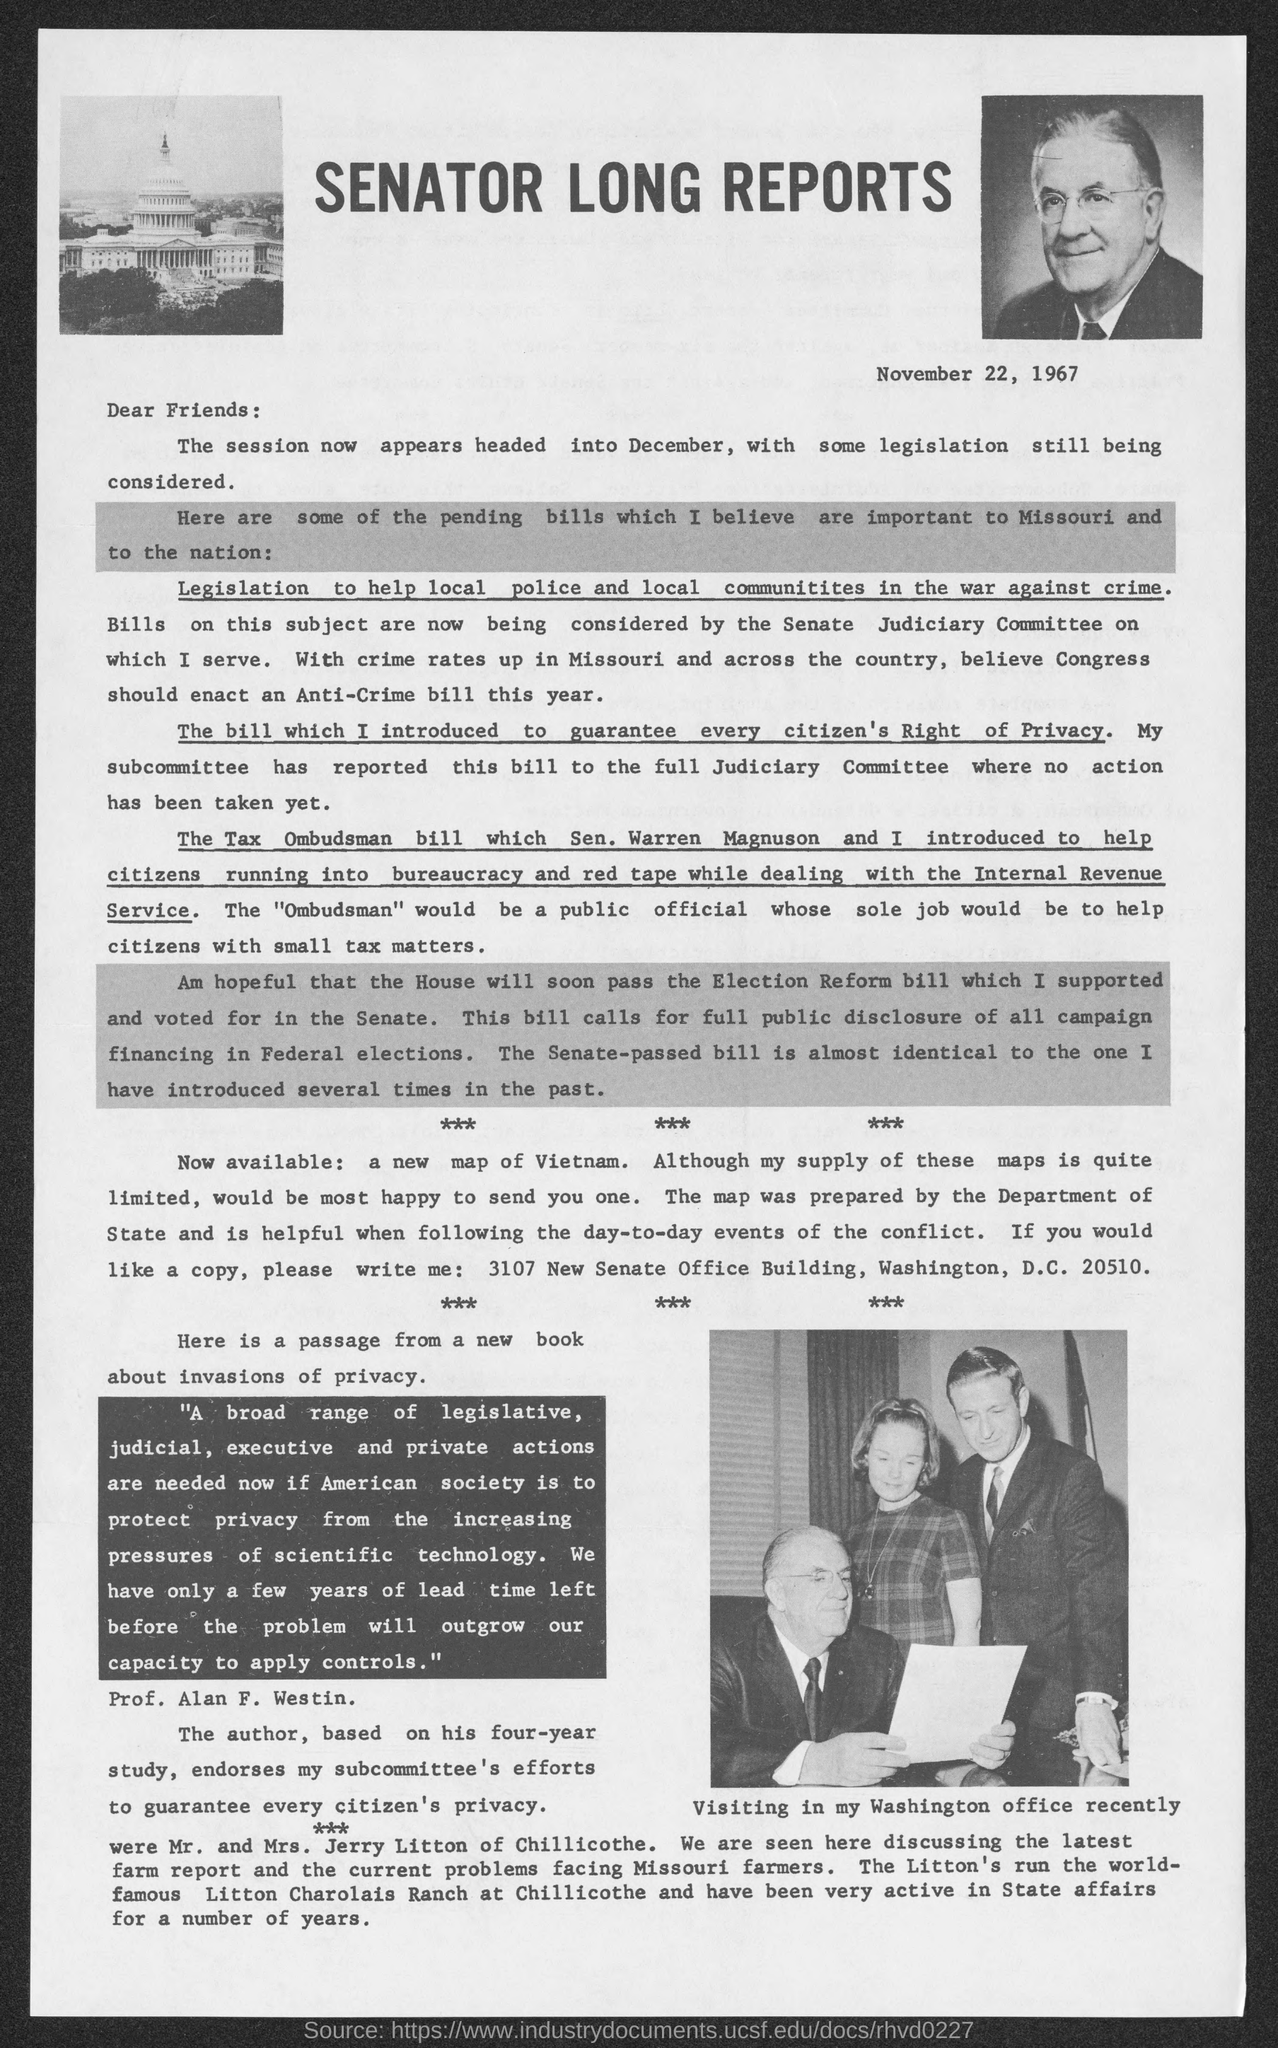On which date was this letter or report written?
Your answer should be very brief. November 22, 1967. What is the title of this letter?
Keep it short and to the point. Senator long reports. In which office did the senator visit recently?
Ensure brevity in your answer.  Washington office. Which is the first underlined word in this passage?
Your response must be concise. Legislation. To whom is this passage addressed?
Make the answer very short. Friends. 